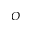<formula> <loc_0><loc_0><loc_500><loc_500>O</formula> 